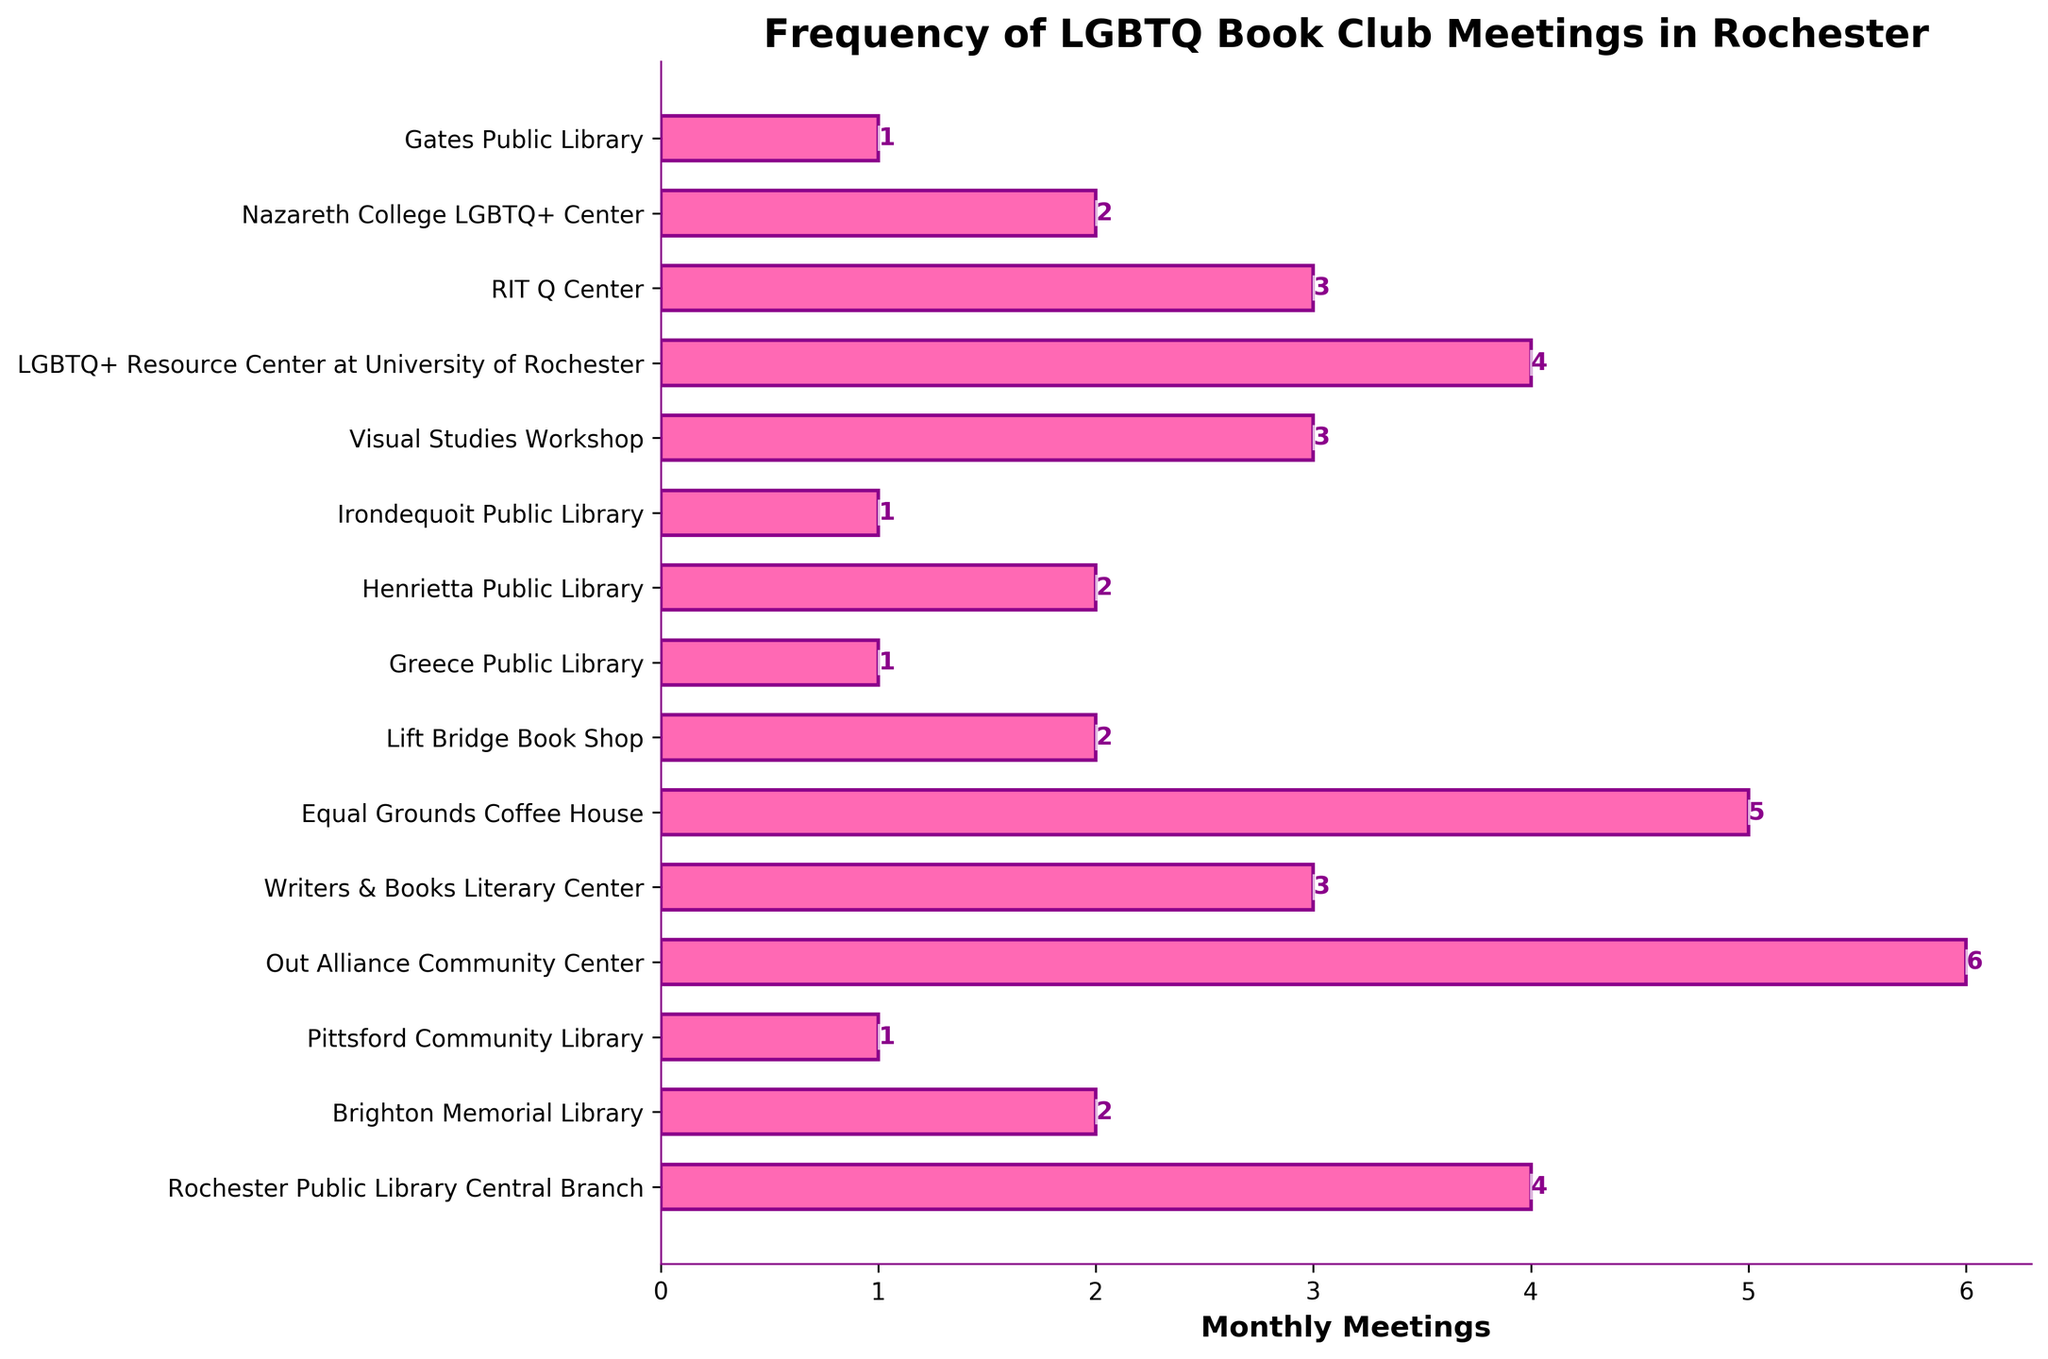Which location has the highest number of monthly LGBTQ book club meetings? To determine the location with the highest number of monthly meetings, look for the bar with the greatest length in the figure. The longest bar represents the Out Alliance Community Center.
Answer: Out Alliance Community Center How many monthly meetings are held at the Rochester Public Library Central Branch and Equal Grounds Coffee House combined? To find the combined total, add the number of meetings at Rochester Public Library Central Branch (4) and Equal Grounds Coffee House (5). The total is 4 + 5 = 9.
Answer: 9 Which location has fewer monthly meetings: Brighton Memorial Library or Lift Bridge Book Shop? Compare the lengths of the bars for Brighton Memorial Library and Lift Bridge Book Shop. Brighton Memorial Library has 2 meetings, and Lift Bridge Book Shop also has 2 meetings. They have an equal number of meetings.
Answer: Equal What's the difference in the number of monthly meetings between Out Alliance Community Center and Pittsford Community Library? Subtract the number of meetings at Pittsford Community Library (1) from the number at Out Alliance Community Center (6). The difference is 6 - 1 = 5.
Answer: 5 How many locations have exactly 2 monthly meetings? Count the bars that correspond to 2 monthly meetings. From the figure, 5 locations have exactly 2 monthly meetings.
Answer: 5 On average, how many monthly meetings are held at the two locations with the highest number of meetings? First, identify the two locations with the highest meetings: Out Alliance Community Center (6) and Equal Grounds Coffee House (5). Then, calculate the average: (6 + 5) / 2 = 5.5.
Answer: 5.5 Which has more monthly meetings: Visual Studies Workshop or Irondequoit Public Library? Compare the lengths of the bars for Visual Studies Workshop (3 meetings) and Irondequoit Public Library (1 meeting). Visual Studies Workshop has more.
Answer: Visual Studies Workshop What is the total number of monthly LGBTQ book club meetings across all locations? Sum the monthly meetings for all locations: 4 + 2 + 1 + 6 + 3 + 5 + 2 + 1 + 2 + 1 + 3 + 4 + 3 + 2 + 1. The total is 40.
Answer: 40 Which color represents the bars for the monthly meetings in the bar chart? By observing the color used in the bars of the figure, we can identify it. The bars are represented in pink.
Answer: Pink How many locations have more than 1 but fewer than 4 monthly meetings? Count the bars that correspond to more than 1 but fewer than 4 monthly meetings. These locations are Brighton Memorial Library (2), Writers & Books Literary Center (3), Lift Bridge Book Shop (2), Henrietta Public Library (2), Visual Studies Workshop (3), RIT Q Center (3), and Nazareth College LGBTQ+ Center (2). Total: 7 locations.
Answer: 7 